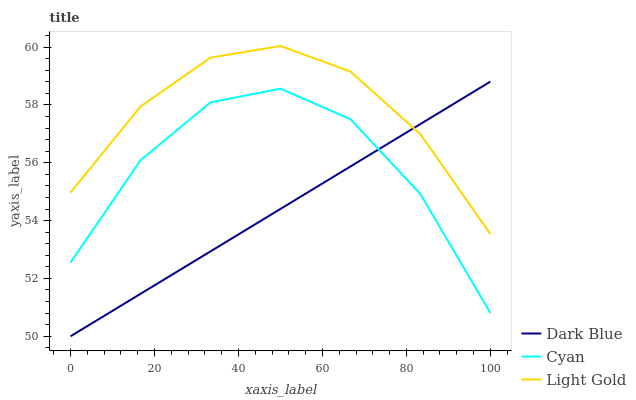Does Cyan have the minimum area under the curve?
Answer yes or no. No. Does Cyan have the maximum area under the curve?
Answer yes or no. No. Is Light Gold the smoothest?
Answer yes or no. No. Is Light Gold the roughest?
Answer yes or no. No. Does Cyan have the lowest value?
Answer yes or no. No. Does Cyan have the highest value?
Answer yes or no. No. Is Cyan less than Light Gold?
Answer yes or no. Yes. Is Light Gold greater than Cyan?
Answer yes or no. Yes. Does Cyan intersect Light Gold?
Answer yes or no. No. 